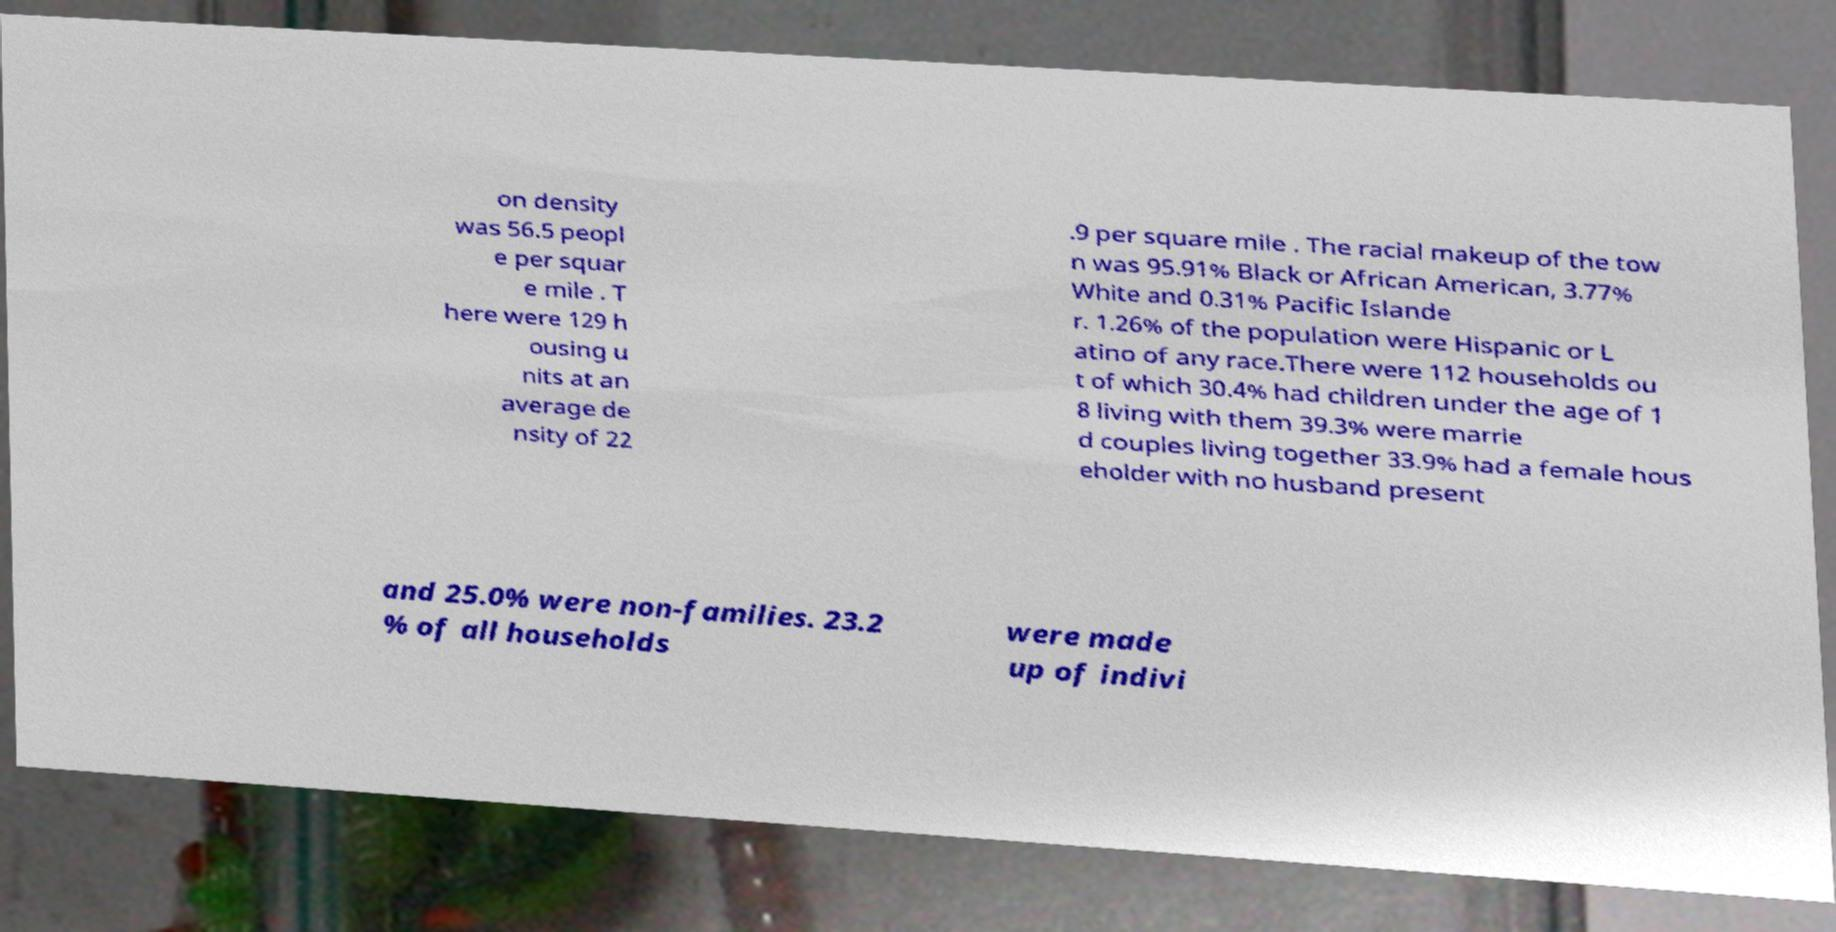For documentation purposes, I need the text within this image transcribed. Could you provide that? on density was 56.5 peopl e per squar e mile . T here were 129 h ousing u nits at an average de nsity of 22 .9 per square mile . The racial makeup of the tow n was 95.91% Black or African American, 3.77% White and 0.31% Pacific Islande r. 1.26% of the population were Hispanic or L atino of any race.There were 112 households ou t of which 30.4% had children under the age of 1 8 living with them 39.3% were marrie d couples living together 33.9% had a female hous eholder with no husband present and 25.0% were non-families. 23.2 % of all households were made up of indivi 